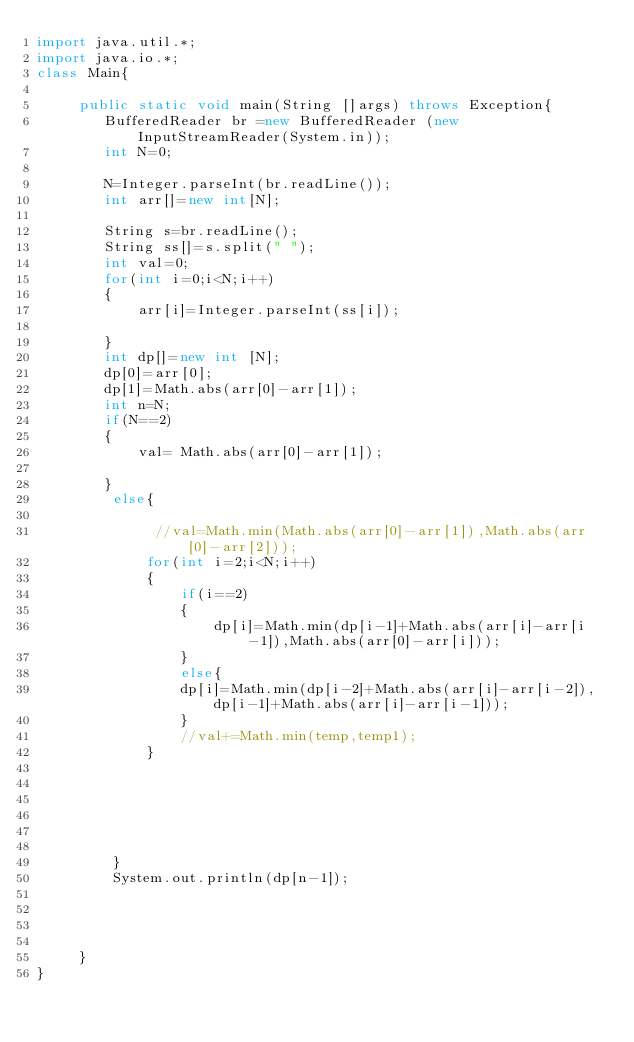Convert code to text. <code><loc_0><loc_0><loc_500><loc_500><_Java_>import java.util.*;
import java.io.*;
class Main{

     public static void main(String []args) throws Exception{
        BufferedReader br =new BufferedReader (new InputStreamReader(System.in));
        int N=0;
        
        N=Integer.parseInt(br.readLine());
        int arr[]=new int[N];
        
        String s=br.readLine();
        String ss[]=s.split(" ");
        int val=0;
        for(int i=0;i<N;i++)
        {
            arr[i]=Integer.parseInt(ss[i]);
            
        }
        int dp[]=new int [N];
        dp[0]=arr[0];
        dp[1]=Math.abs(arr[0]-arr[1]);      
        int n=N;         
        if(N==2)
        {
            val= Math.abs(arr[0]-arr[1]);
            
        }
         else{
             
              //val=Math.min(Math.abs(arr[0]-arr[1]),Math.abs(arr[0]-arr[2]));
             for(int i=2;i<N;i++)
             {
                 if(i==2)
                 {
                     dp[i]=Math.min(dp[i-1]+Math.abs(arr[i]-arr[i-1]),Math.abs(arr[0]-arr[i]));
                 }
                 else{
                 dp[i]=Math.min(dp[i-2]+Math.abs(arr[i]-arr[i-2]),dp[i-1]+Math.abs(arr[i]-arr[i-1]));
                 }
                 //val+=Math.min(temp,temp1);
             }
             
             
             
             
             
             
         }
         System.out.println(dp[n-1]);
         
         
         
         
     }
}</code> 